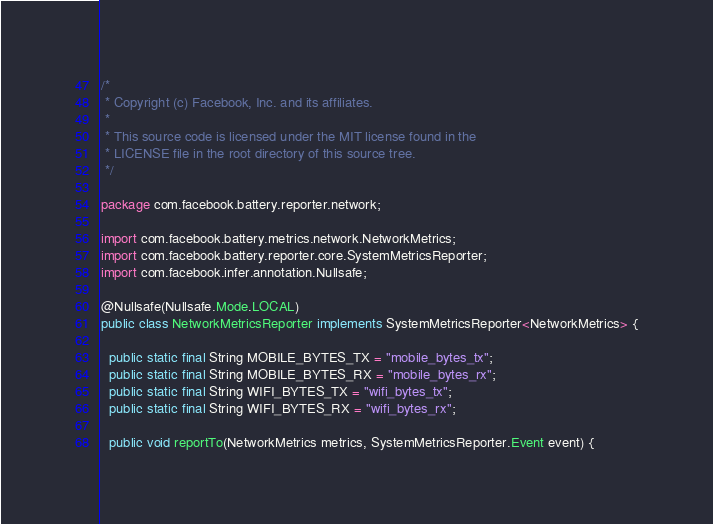Convert code to text. <code><loc_0><loc_0><loc_500><loc_500><_Java_>/*
 * Copyright (c) Facebook, Inc. and its affiliates.
 *
 * This source code is licensed under the MIT license found in the
 * LICENSE file in the root directory of this source tree.
 */

package com.facebook.battery.reporter.network;

import com.facebook.battery.metrics.network.NetworkMetrics;
import com.facebook.battery.reporter.core.SystemMetricsReporter;
import com.facebook.infer.annotation.Nullsafe;

@Nullsafe(Nullsafe.Mode.LOCAL)
public class NetworkMetricsReporter implements SystemMetricsReporter<NetworkMetrics> {

  public static final String MOBILE_BYTES_TX = "mobile_bytes_tx";
  public static final String MOBILE_BYTES_RX = "mobile_bytes_rx";
  public static final String WIFI_BYTES_TX = "wifi_bytes_tx";
  public static final String WIFI_BYTES_RX = "wifi_bytes_rx";

  public void reportTo(NetworkMetrics metrics, SystemMetricsReporter.Event event) {</code> 